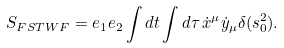Convert formula to latex. <formula><loc_0><loc_0><loc_500><loc_500>S _ { F S T W F } = e _ { 1 } e _ { 2 } \int d t \int d \tau \, \dot { x } ^ { \mu } \dot { y } _ { \mu } \delta ( s ^ { 2 } _ { 0 } ) .</formula> 